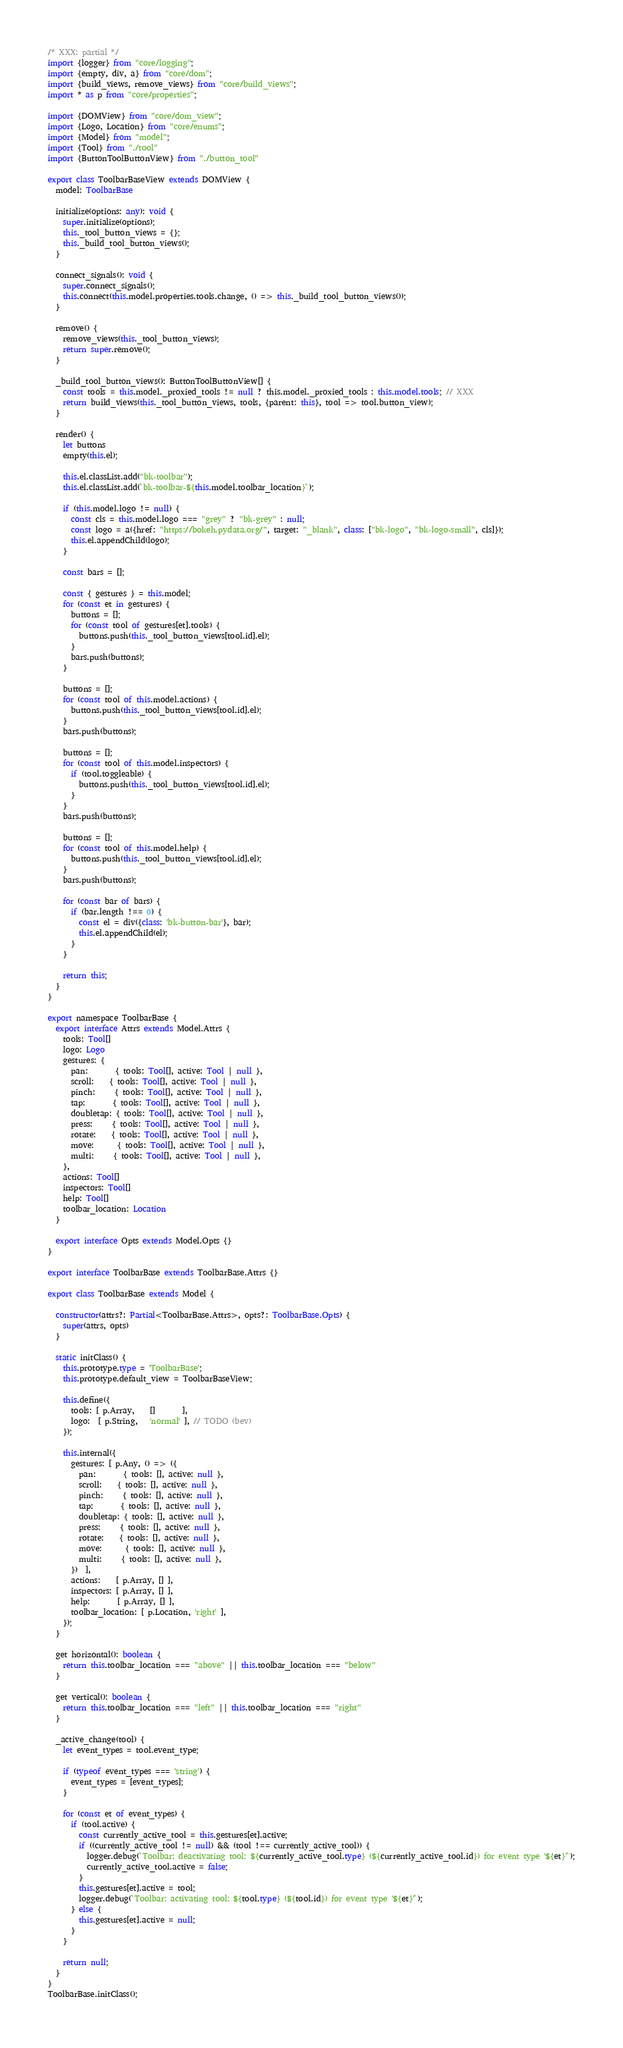<code> <loc_0><loc_0><loc_500><loc_500><_TypeScript_>/* XXX: partial */
import {logger} from "core/logging";
import {empty, div, a} from "core/dom";
import {build_views, remove_views} from "core/build_views";
import * as p from "core/properties";

import {DOMView} from "core/dom_view";
import {Logo, Location} from "core/enums";
import {Model} from "model";
import {Tool} from "./tool"
import {ButtonToolButtonView} from "./button_tool"

export class ToolbarBaseView extends DOMView {
  model: ToolbarBase

  initialize(options: any): void {
    super.initialize(options);
    this._tool_button_views = {};
    this._build_tool_button_views();
  }

  connect_signals(): void {
    super.connect_signals();
    this.connect(this.model.properties.tools.change, () => this._build_tool_button_views());
  }

  remove() {
    remove_views(this._tool_button_views);
    return super.remove();
  }

  _build_tool_button_views(): ButtonToolButtonView[] {
    const tools = this.model._proxied_tools != null ? this.model._proxied_tools : this.model.tools; // XXX
    return build_views(this._tool_button_views, tools, {parent: this}, tool => tool.button_view);
  }

  render() {
    let buttons
    empty(this.el);

    this.el.classList.add("bk-toolbar");
    this.el.classList.add(`bk-toolbar-${this.model.toolbar_location}`);

    if (this.model.logo != null) {
      const cls = this.model.logo === "grey" ? "bk-grey" : null;
      const logo = a({href: "https://bokeh.pydata.org/", target: "_blank", class: ["bk-logo", "bk-logo-small", cls]});
      this.el.appendChild(logo);
    }

    const bars = [];

    const { gestures } = this.model;
    for (const et in gestures) {
      buttons = [];
      for (const tool of gestures[et].tools) {
        buttons.push(this._tool_button_views[tool.id].el);
      }
      bars.push(buttons);
    }

    buttons = [];
    for (const tool of this.model.actions) {
      buttons.push(this._tool_button_views[tool.id].el);
    }
    bars.push(buttons);

    buttons = [];
    for (const tool of this.model.inspectors) {
      if (tool.toggleable) {
        buttons.push(this._tool_button_views[tool.id].el);
      }
    }
    bars.push(buttons);

    buttons = [];
    for (const tool of this.model.help) {
      buttons.push(this._tool_button_views[tool.id].el);
    }
    bars.push(buttons);

    for (const bar of bars) {
      if (bar.length !== 0) {
        const el = div({class: 'bk-button-bar'}, bar);
        this.el.appendChild(el);
      }
    }

    return this;
  }
}

export namespace ToolbarBase {
  export interface Attrs extends Model.Attrs {
    tools: Tool[]
    logo: Logo
    gestures: {
      pan:       { tools: Tool[], active: Tool | null },
      scroll:    { tools: Tool[], active: Tool | null },
      pinch:     { tools: Tool[], active: Tool | null },
      tap:       { tools: Tool[], active: Tool | null },
      doubletap: { tools: Tool[], active: Tool | null },
      press:     { tools: Tool[], active: Tool | null },
      rotate:    { tools: Tool[], active: Tool | null },
      move:      { tools: Tool[], active: Tool | null },
      multi:     { tools: Tool[], active: Tool | null },
    },
    actions: Tool[]
    inspectors: Tool[]
    help: Tool[]
    toolbar_location: Location
  }

  export interface Opts extends Model.Opts {}
}

export interface ToolbarBase extends ToolbarBase.Attrs {}

export class ToolbarBase extends Model {

  constructor(attrs?: Partial<ToolbarBase.Attrs>, opts?: ToolbarBase.Opts) {
    super(attrs, opts)
  }

  static initClass() {
    this.prototype.type = 'ToolbarBase';
    this.prototype.default_view = ToolbarBaseView;

    this.define({
      tools: [ p.Array,    []       ],
      logo:  [ p.String,   'normal' ], // TODO (bev)
    });

    this.internal({
      gestures: [ p.Any, () => ({
        pan:       { tools: [], active: null },
        scroll:    { tools: [], active: null },
        pinch:     { tools: [], active: null },
        tap:       { tools: [], active: null },
        doubletap: { tools: [], active: null },
        press:     { tools: [], active: null },
        rotate:    { tools: [], active: null },
        move:      { tools: [], active: null },
        multi:     { tools: [], active: null },
      })  ],
      actions:    [ p.Array, [] ],
      inspectors: [ p.Array, [] ],
      help:       [ p.Array, [] ],
      toolbar_location: [ p.Location, 'right' ],
    });
  }

  get horizontal(): boolean {
    return this.toolbar_location === "above" || this.toolbar_location === "below"
  }

  get vertical(): boolean {
    return this.toolbar_location === "left" || this.toolbar_location === "right"
  }

  _active_change(tool) {
    let event_types = tool.event_type;

    if (typeof event_types === 'string') {
      event_types = [event_types];
    }

    for (const et of event_types) {
      if (tool.active) {
        const currently_active_tool = this.gestures[et].active;
        if ((currently_active_tool != null) && (tool !== currently_active_tool)) {
          logger.debug(`Toolbar: deactivating tool: ${currently_active_tool.type} (${currently_active_tool.id}) for event type '${et}'`);
          currently_active_tool.active = false;
        }
        this.gestures[et].active = tool;
        logger.debug(`Toolbar: activating tool: ${tool.type} (${tool.id}) for event type '${et}'`);
      } else {
        this.gestures[et].active = null;
      }
    }

    return null;
  }
}
ToolbarBase.initClass();
</code> 